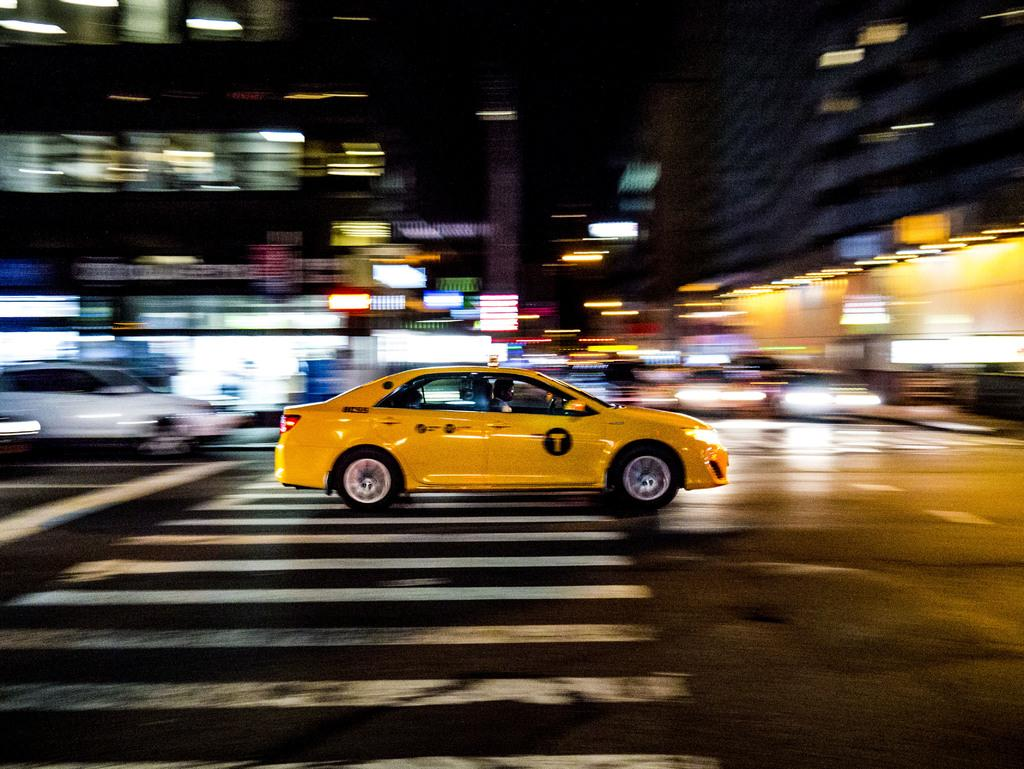<image>
Share a concise interpretation of the image provided. A yellow taxi with a large yellow capital T in a black circle races over a crosswalk on a city street with a blurred background. 